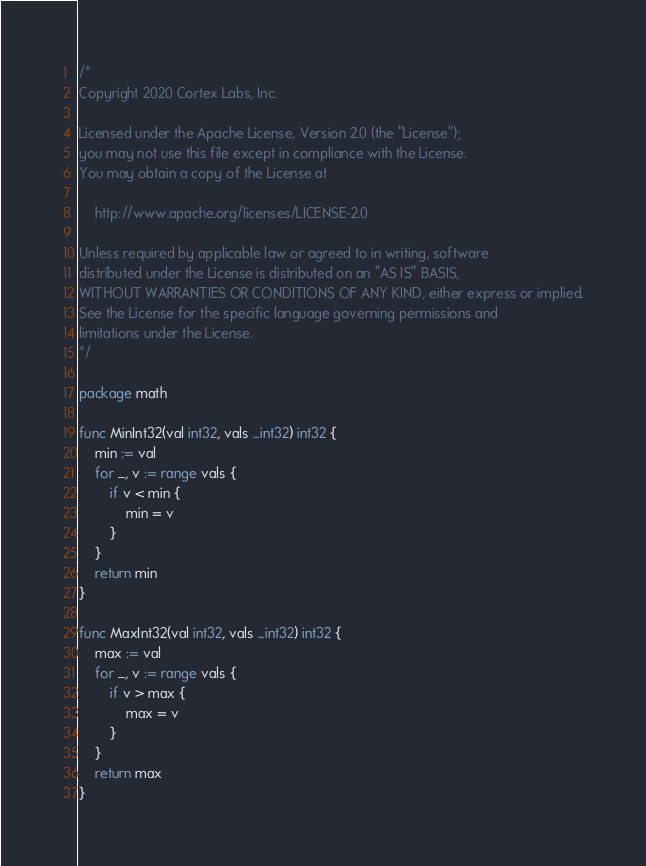<code> <loc_0><loc_0><loc_500><loc_500><_Go_>/*
Copyright 2020 Cortex Labs, Inc.

Licensed under the Apache License, Version 2.0 (the "License");
you may not use this file except in compliance with the License.
You may obtain a copy of the License at

    http://www.apache.org/licenses/LICENSE-2.0

Unless required by applicable law or agreed to in writing, software
distributed under the License is distributed on an "AS IS" BASIS,
WITHOUT WARRANTIES OR CONDITIONS OF ANY KIND, either express or implied.
See the License for the specific language governing permissions and
limitations under the License.
*/

package math

func MinInt32(val int32, vals ...int32) int32 {
	min := val
	for _, v := range vals {
		if v < min {
			min = v
		}
	}
	return min
}

func MaxInt32(val int32, vals ...int32) int32 {
	max := val
	for _, v := range vals {
		if v > max {
			max = v
		}
	}
	return max
}
</code> 